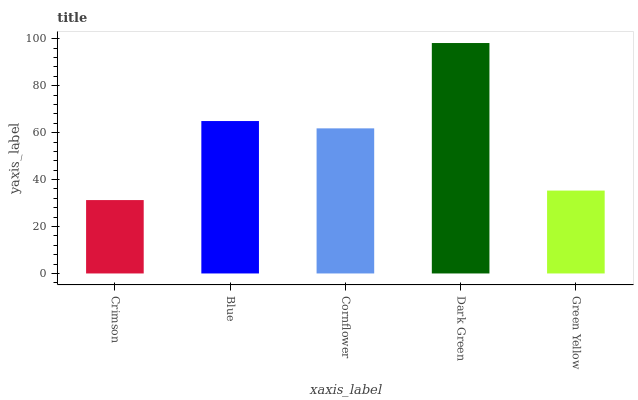Is Crimson the minimum?
Answer yes or no. Yes. Is Dark Green the maximum?
Answer yes or no. Yes. Is Blue the minimum?
Answer yes or no. No. Is Blue the maximum?
Answer yes or no. No. Is Blue greater than Crimson?
Answer yes or no. Yes. Is Crimson less than Blue?
Answer yes or no. Yes. Is Crimson greater than Blue?
Answer yes or no. No. Is Blue less than Crimson?
Answer yes or no. No. Is Cornflower the high median?
Answer yes or no. Yes. Is Cornflower the low median?
Answer yes or no. Yes. Is Dark Green the high median?
Answer yes or no. No. Is Dark Green the low median?
Answer yes or no. No. 